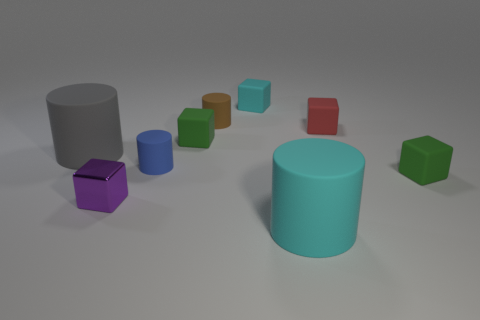What number of big things are cyan rubber blocks or red metallic cylinders?
Your answer should be compact. 0. Are there any other things that are the same color as the small shiny block?
Provide a short and direct response. No. What is the material of the cube left of the green thing that is left of the tiny matte block in front of the big gray thing?
Your response must be concise. Metal. How many rubber things are large blue spheres or cyan objects?
Your answer should be compact. 2. What number of gray objects are tiny shiny blocks or small cylinders?
Provide a short and direct response. 0. Do the large cylinder in front of the big gray object and the metallic block have the same color?
Provide a succinct answer. No. Are the tiny cyan object and the small blue thing made of the same material?
Make the answer very short. Yes. Is the number of big gray cylinders that are to the right of the gray cylinder the same as the number of small brown matte cylinders in front of the big cyan rubber cylinder?
Provide a succinct answer. Yes. There is a tiny cyan object that is the same shape as the purple shiny object; what material is it?
Your answer should be compact. Rubber. There is a cyan thing that is behind the green rubber thing to the left of the large cylinder to the right of the tiny brown cylinder; what is its shape?
Offer a very short reply. Cube. 